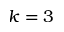Convert formula to latex. <formula><loc_0><loc_0><loc_500><loc_500>k = 3</formula> 